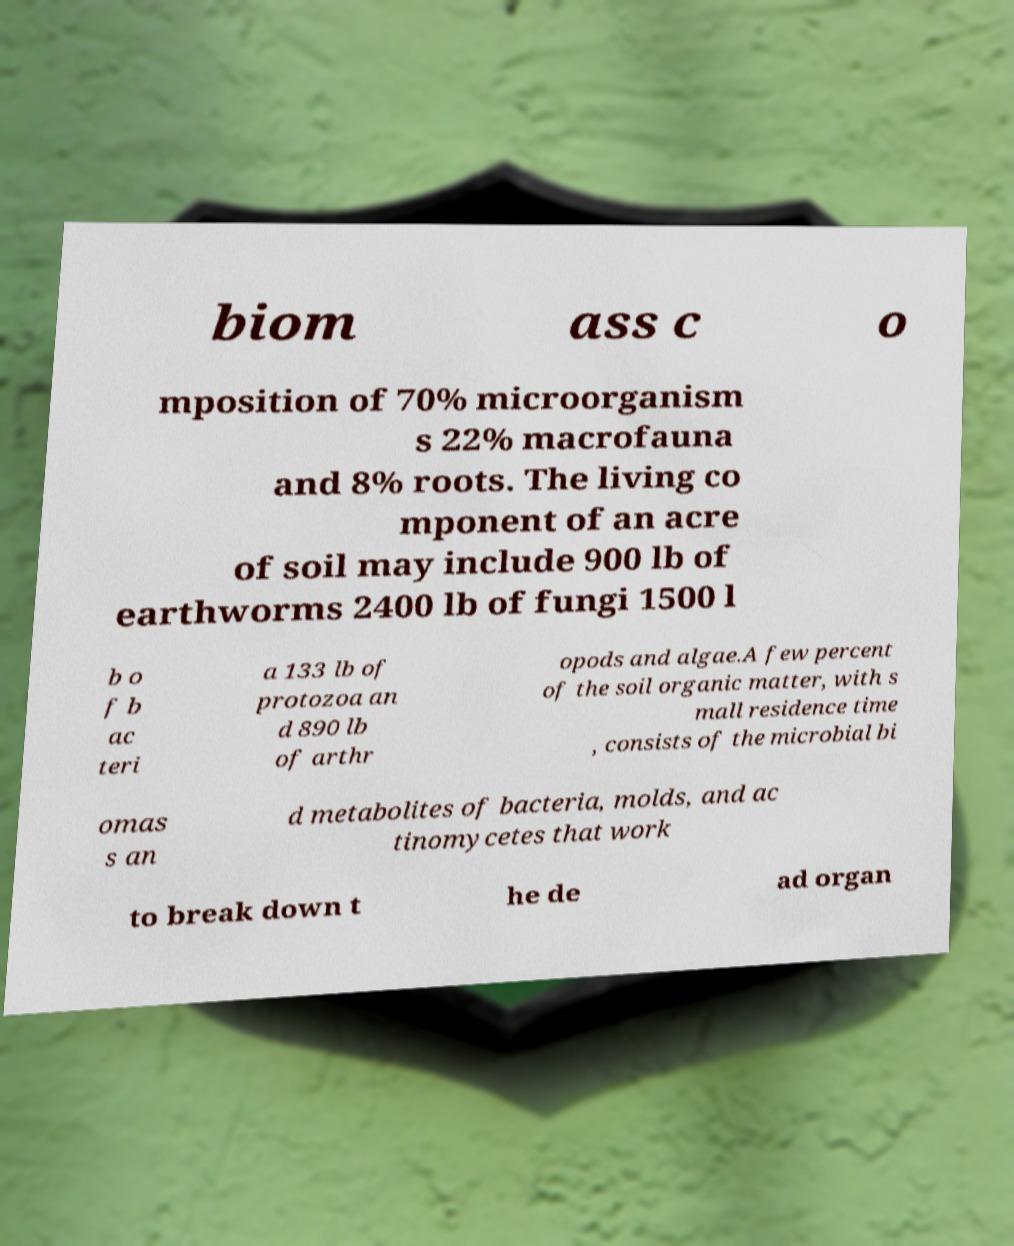There's text embedded in this image that I need extracted. Can you transcribe it verbatim? biom ass c o mposition of 70% microorganism s 22% macrofauna and 8% roots. The living co mponent of an acre of soil may include 900 lb of earthworms 2400 lb of fungi 1500 l b o f b ac teri a 133 lb of protozoa an d 890 lb of arthr opods and algae.A few percent of the soil organic matter, with s mall residence time , consists of the microbial bi omas s an d metabolites of bacteria, molds, and ac tinomycetes that work to break down t he de ad organ 